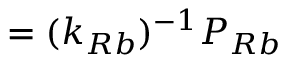Convert formula to latex. <formula><loc_0><loc_0><loc_500><loc_500>= ( k _ { R b } ) ^ { - 1 } P _ { R b }</formula> 